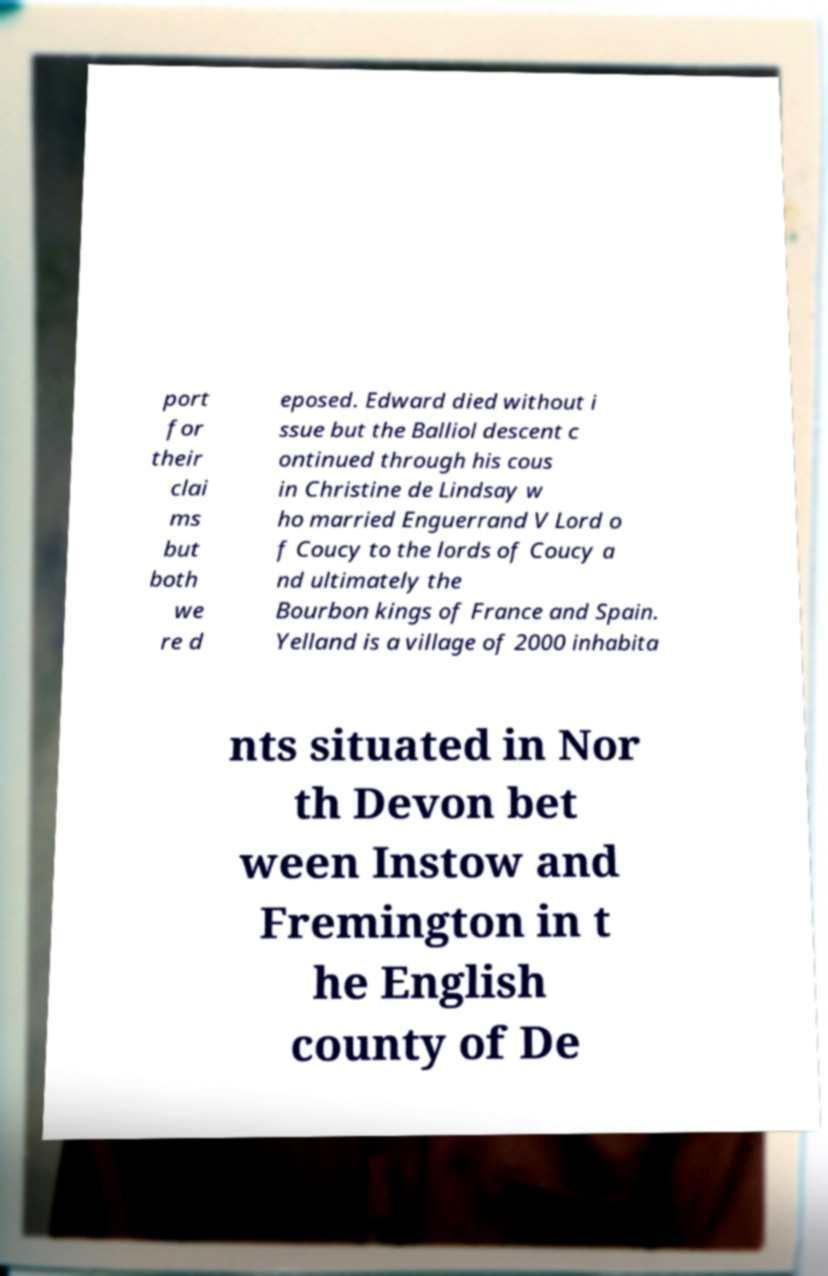What messages or text are displayed in this image? I need them in a readable, typed format. port for their clai ms but both we re d eposed. Edward died without i ssue but the Balliol descent c ontinued through his cous in Christine de Lindsay w ho married Enguerrand V Lord o f Coucy to the lords of Coucy a nd ultimately the Bourbon kings of France and Spain. Yelland is a village of 2000 inhabita nts situated in Nor th Devon bet ween Instow and Fremington in t he English county of De 